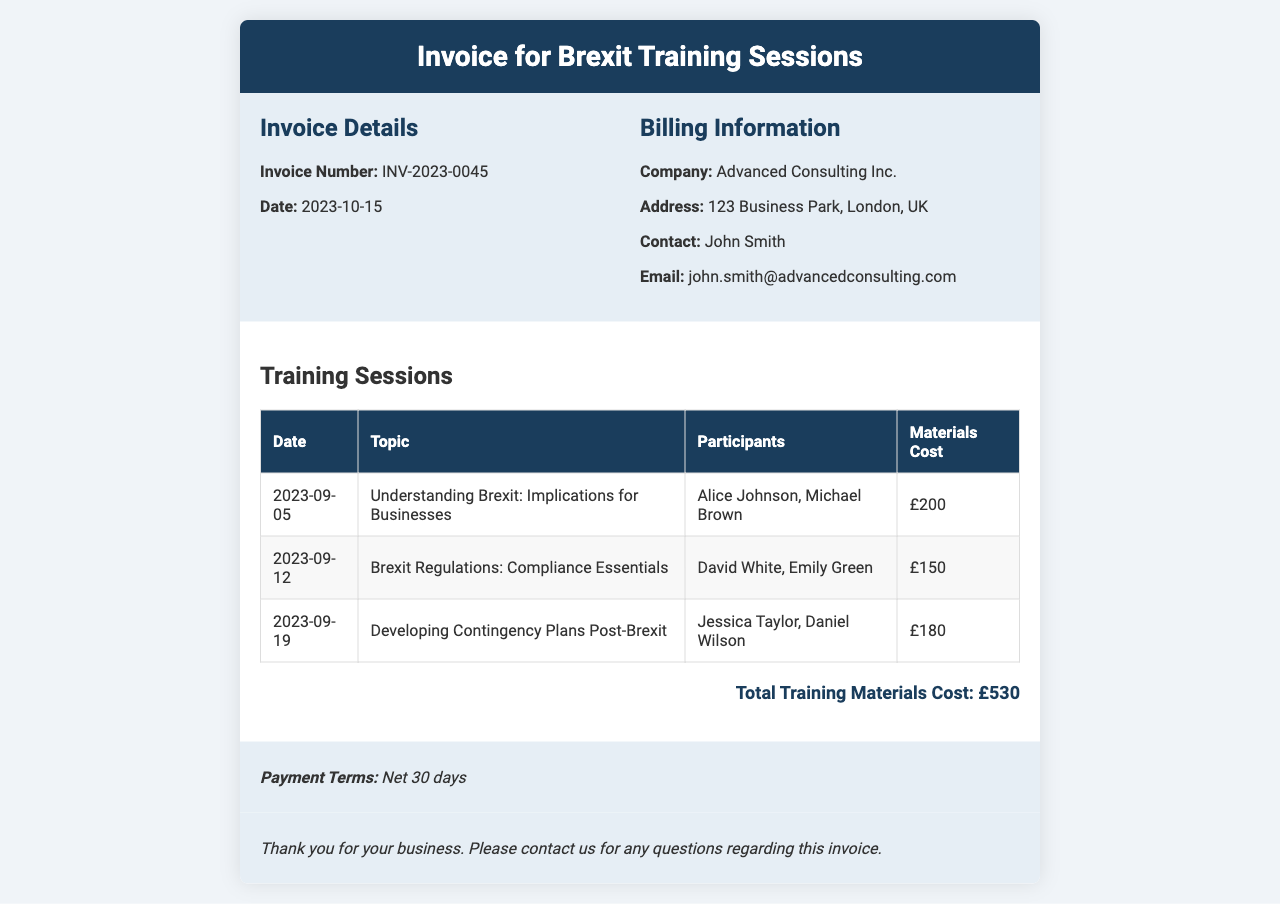What is the invoice number? The invoice number is mentioned in the document under the invoice details section.
Answer: INV-2023-0045 What is the total cost of training materials? The total cost of training materials is summarised at the bottom of the training sessions section.
Answer: £530 Who are the participants in the session on 2023-09-12? The participants for that session are listed alongside the date and topic within the table.
Answer: David White, Emily Green What is the payment term for this invoice? The payment terms are specified at the bottom of the document, indicating how long the company has to pay the invoice.
Answer: Net 30 days What was the topic of the training on 2023-09-19? The topic can be found in the row corresponding to the date in the training sessions table.
Answer: Developing Contingency Plans Post-Brexit How many training sessions are listed in the document? The number of training sessions can be determined by counting the rows in the training sessions table.
Answer: 3 What is the address of the company being billed? The company address is found in the billing information section of the invoice.
Answer: 123 Business Park, London, UK 